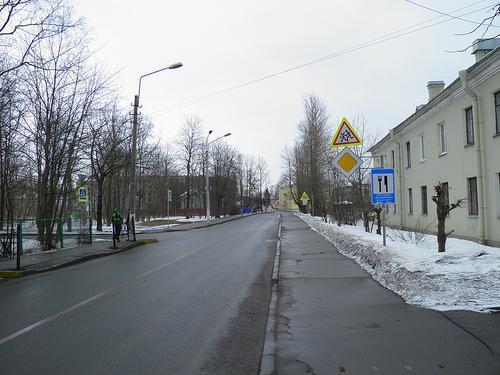How many people are in the photo?
Give a very brief answer. 2. 